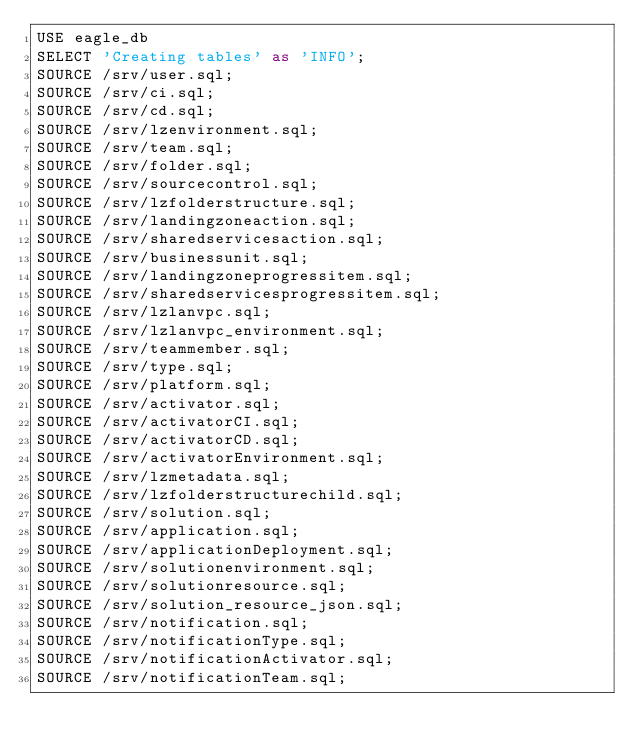Convert code to text. <code><loc_0><loc_0><loc_500><loc_500><_SQL_>USE eagle_db
SELECT 'Creating tables' as 'INFO';
SOURCE /srv/user.sql;
SOURCE /srv/ci.sql;
SOURCE /srv/cd.sql;
SOURCE /srv/lzenvironment.sql;
SOURCE /srv/team.sql;
SOURCE /srv/folder.sql;
SOURCE /srv/sourcecontrol.sql;
SOURCE /srv/lzfolderstructure.sql;
SOURCE /srv/landingzoneaction.sql;
SOURCE /srv/sharedservicesaction.sql;
SOURCE /srv/businessunit.sql;
SOURCE /srv/landingzoneprogressitem.sql;
SOURCE /srv/sharedservicesprogressitem.sql;
SOURCE /srv/lzlanvpc.sql;
SOURCE /srv/lzlanvpc_environment.sql;
SOURCE /srv/teammember.sql;
SOURCE /srv/type.sql;
SOURCE /srv/platform.sql;
SOURCE /srv/activator.sql;
SOURCE /srv/activatorCI.sql;
SOURCE /srv/activatorCD.sql;
SOURCE /srv/activatorEnvironment.sql;
SOURCE /srv/lzmetadata.sql;
SOURCE /srv/lzfolderstructurechild.sql;
SOURCE /srv/solution.sql;
SOURCE /srv/application.sql;
SOURCE /srv/applicationDeployment.sql;
SOURCE /srv/solutionenvironment.sql;
SOURCE /srv/solutionresource.sql;
SOURCE /srv/solution_resource_json.sql;
SOURCE /srv/notification.sql;
SOURCE /srv/notificationType.sql;
SOURCE /srv/notificationActivator.sql;
SOURCE /srv/notificationTeam.sql;</code> 